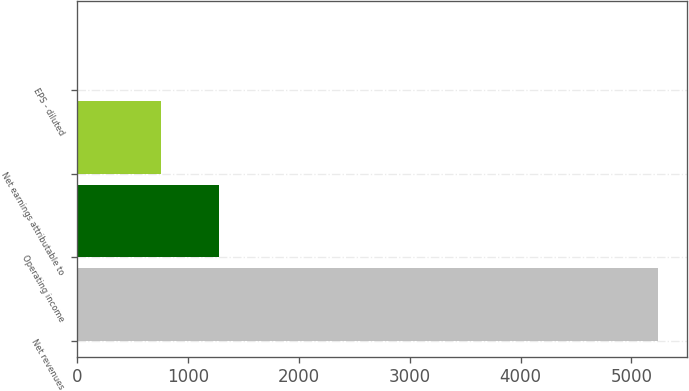<chart> <loc_0><loc_0><loc_500><loc_500><bar_chart><fcel>Net revenues<fcel>Operating income<fcel>Net earnings attributable to<fcel>EPS - diluted<nl><fcel>5238<fcel>1277.85<fcel>754.1<fcel>0.51<nl></chart> 